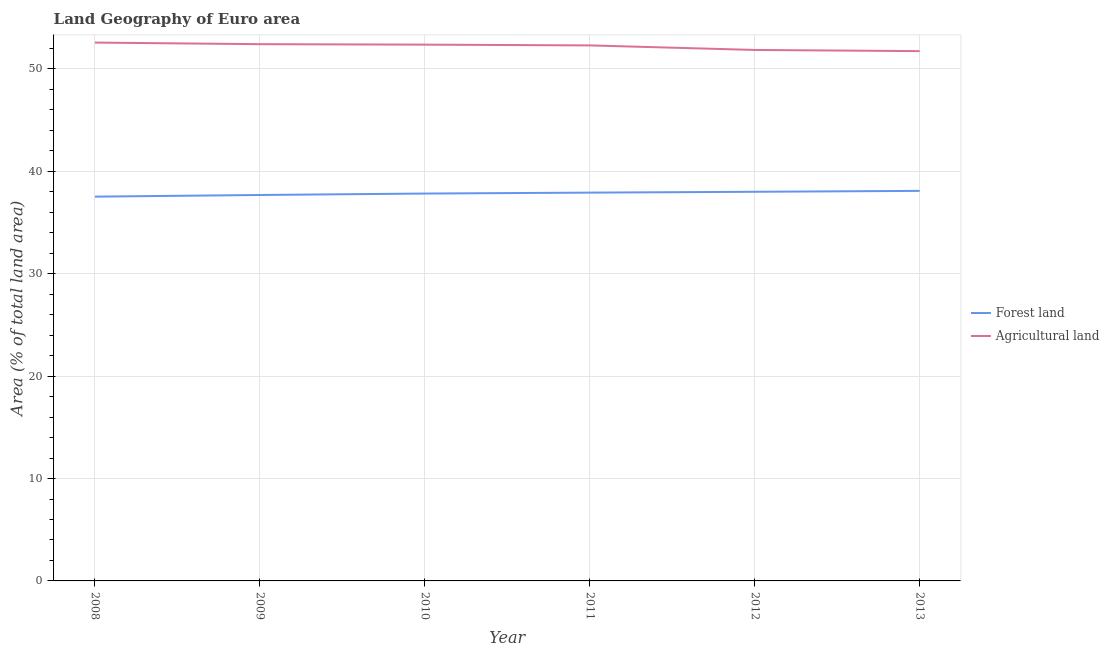Does the line corresponding to percentage of land area under agriculture intersect with the line corresponding to percentage of land area under forests?
Your answer should be very brief. No. Is the number of lines equal to the number of legend labels?
Make the answer very short. Yes. What is the percentage of land area under forests in 2012?
Provide a short and direct response. 38.01. Across all years, what is the maximum percentage of land area under forests?
Provide a short and direct response. 38.09. Across all years, what is the minimum percentage of land area under agriculture?
Provide a short and direct response. 51.74. What is the total percentage of land area under forests in the graph?
Give a very brief answer. 227.08. What is the difference between the percentage of land area under agriculture in 2010 and that in 2013?
Provide a succinct answer. 0.63. What is the difference between the percentage of land area under forests in 2011 and the percentage of land area under agriculture in 2012?
Provide a succinct answer. -13.93. What is the average percentage of land area under forests per year?
Your answer should be very brief. 37.85. In the year 2009, what is the difference between the percentage of land area under forests and percentage of land area under agriculture?
Provide a short and direct response. -14.73. In how many years, is the percentage of land area under forests greater than 22 %?
Provide a short and direct response. 6. What is the ratio of the percentage of land area under agriculture in 2008 to that in 2013?
Ensure brevity in your answer.  1.02. Is the percentage of land area under forests in 2011 less than that in 2013?
Offer a very short reply. Yes. What is the difference between the highest and the second highest percentage of land area under agriculture?
Provide a short and direct response. 0.16. What is the difference between the highest and the lowest percentage of land area under agriculture?
Provide a short and direct response. 0.83. Is the sum of the percentage of land area under agriculture in 2011 and 2013 greater than the maximum percentage of land area under forests across all years?
Make the answer very short. Yes. Is the percentage of land area under forests strictly less than the percentage of land area under agriculture over the years?
Offer a very short reply. Yes. How many years are there in the graph?
Keep it short and to the point. 6. What is the difference between two consecutive major ticks on the Y-axis?
Your response must be concise. 10. Does the graph contain any zero values?
Keep it short and to the point. No. Does the graph contain grids?
Provide a succinct answer. Yes. Where does the legend appear in the graph?
Your response must be concise. Center right. How are the legend labels stacked?
Offer a very short reply. Vertical. What is the title of the graph?
Offer a very short reply. Land Geography of Euro area. Does "Time to import" appear as one of the legend labels in the graph?
Give a very brief answer. No. What is the label or title of the Y-axis?
Make the answer very short. Area (% of total land area). What is the Area (% of total land area) of Forest land in 2008?
Provide a short and direct response. 37.53. What is the Area (% of total land area) in Agricultural land in 2008?
Keep it short and to the point. 52.58. What is the Area (% of total land area) in Forest land in 2009?
Give a very brief answer. 37.69. What is the Area (% of total land area) of Agricultural land in 2009?
Make the answer very short. 52.42. What is the Area (% of total land area) of Forest land in 2010?
Your answer should be very brief. 37.83. What is the Area (% of total land area) of Agricultural land in 2010?
Provide a succinct answer. 52.38. What is the Area (% of total land area) in Forest land in 2011?
Provide a short and direct response. 37.92. What is the Area (% of total land area) of Agricultural land in 2011?
Offer a very short reply. 52.3. What is the Area (% of total land area) in Forest land in 2012?
Ensure brevity in your answer.  38.01. What is the Area (% of total land area) in Agricultural land in 2012?
Provide a short and direct response. 51.86. What is the Area (% of total land area) in Forest land in 2013?
Offer a terse response. 38.09. What is the Area (% of total land area) of Agricultural land in 2013?
Ensure brevity in your answer.  51.74. Across all years, what is the maximum Area (% of total land area) of Forest land?
Give a very brief answer. 38.09. Across all years, what is the maximum Area (% of total land area) of Agricultural land?
Keep it short and to the point. 52.58. Across all years, what is the minimum Area (% of total land area) in Forest land?
Keep it short and to the point. 37.53. Across all years, what is the minimum Area (% of total land area) in Agricultural land?
Your answer should be very brief. 51.74. What is the total Area (% of total land area) of Forest land in the graph?
Give a very brief answer. 227.08. What is the total Area (% of total land area) of Agricultural land in the graph?
Make the answer very short. 313.28. What is the difference between the Area (% of total land area) in Forest land in 2008 and that in 2009?
Provide a succinct answer. -0.16. What is the difference between the Area (% of total land area) in Agricultural land in 2008 and that in 2009?
Provide a short and direct response. 0.16. What is the difference between the Area (% of total land area) of Forest land in 2008 and that in 2010?
Your answer should be compact. -0.3. What is the difference between the Area (% of total land area) in Agricultural land in 2008 and that in 2010?
Give a very brief answer. 0.2. What is the difference between the Area (% of total land area) of Forest land in 2008 and that in 2011?
Provide a short and direct response. -0.39. What is the difference between the Area (% of total land area) of Agricultural land in 2008 and that in 2011?
Make the answer very short. 0.28. What is the difference between the Area (% of total land area) in Forest land in 2008 and that in 2012?
Your answer should be compact. -0.48. What is the difference between the Area (% of total land area) of Agricultural land in 2008 and that in 2012?
Keep it short and to the point. 0.72. What is the difference between the Area (% of total land area) in Forest land in 2008 and that in 2013?
Your answer should be very brief. -0.56. What is the difference between the Area (% of total land area) in Agricultural land in 2008 and that in 2013?
Your answer should be compact. 0.83. What is the difference between the Area (% of total land area) of Forest land in 2009 and that in 2010?
Offer a very short reply. -0.14. What is the difference between the Area (% of total land area) in Agricultural land in 2009 and that in 2010?
Offer a very short reply. 0.05. What is the difference between the Area (% of total land area) of Forest land in 2009 and that in 2011?
Your response must be concise. -0.23. What is the difference between the Area (% of total land area) of Agricultural land in 2009 and that in 2011?
Keep it short and to the point. 0.12. What is the difference between the Area (% of total land area) in Forest land in 2009 and that in 2012?
Your response must be concise. -0.31. What is the difference between the Area (% of total land area) in Agricultural land in 2009 and that in 2012?
Your response must be concise. 0.57. What is the difference between the Area (% of total land area) in Forest land in 2009 and that in 2013?
Provide a succinct answer. -0.4. What is the difference between the Area (% of total land area) of Agricultural land in 2009 and that in 2013?
Provide a succinct answer. 0.68. What is the difference between the Area (% of total land area) of Forest land in 2010 and that in 2011?
Provide a short and direct response. -0.09. What is the difference between the Area (% of total land area) in Agricultural land in 2010 and that in 2011?
Ensure brevity in your answer.  0.08. What is the difference between the Area (% of total land area) in Forest land in 2010 and that in 2012?
Ensure brevity in your answer.  -0.17. What is the difference between the Area (% of total land area) in Agricultural land in 2010 and that in 2012?
Give a very brief answer. 0.52. What is the difference between the Area (% of total land area) of Forest land in 2010 and that in 2013?
Ensure brevity in your answer.  -0.26. What is the difference between the Area (% of total land area) in Agricultural land in 2010 and that in 2013?
Give a very brief answer. 0.63. What is the difference between the Area (% of total land area) of Forest land in 2011 and that in 2012?
Provide a short and direct response. -0.08. What is the difference between the Area (% of total land area) of Agricultural land in 2011 and that in 2012?
Your answer should be compact. 0.44. What is the difference between the Area (% of total land area) of Forest land in 2011 and that in 2013?
Your response must be concise. -0.17. What is the difference between the Area (% of total land area) in Agricultural land in 2011 and that in 2013?
Keep it short and to the point. 0.56. What is the difference between the Area (% of total land area) in Forest land in 2012 and that in 2013?
Make the answer very short. -0.09. What is the difference between the Area (% of total land area) of Agricultural land in 2012 and that in 2013?
Offer a very short reply. 0.11. What is the difference between the Area (% of total land area) of Forest land in 2008 and the Area (% of total land area) of Agricultural land in 2009?
Ensure brevity in your answer.  -14.89. What is the difference between the Area (% of total land area) of Forest land in 2008 and the Area (% of total land area) of Agricultural land in 2010?
Your response must be concise. -14.85. What is the difference between the Area (% of total land area) of Forest land in 2008 and the Area (% of total land area) of Agricultural land in 2011?
Ensure brevity in your answer.  -14.77. What is the difference between the Area (% of total land area) in Forest land in 2008 and the Area (% of total land area) in Agricultural land in 2012?
Your answer should be compact. -14.33. What is the difference between the Area (% of total land area) of Forest land in 2008 and the Area (% of total land area) of Agricultural land in 2013?
Make the answer very short. -14.21. What is the difference between the Area (% of total land area) of Forest land in 2009 and the Area (% of total land area) of Agricultural land in 2010?
Give a very brief answer. -14.68. What is the difference between the Area (% of total land area) in Forest land in 2009 and the Area (% of total land area) in Agricultural land in 2011?
Your response must be concise. -14.61. What is the difference between the Area (% of total land area) of Forest land in 2009 and the Area (% of total land area) of Agricultural land in 2012?
Offer a terse response. -14.16. What is the difference between the Area (% of total land area) of Forest land in 2009 and the Area (% of total land area) of Agricultural land in 2013?
Provide a succinct answer. -14.05. What is the difference between the Area (% of total land area) of Forest land in 2010 and the Area (% of total land area) of Agricultural land in 2011?
Your answer should be compact. -14.47. What is the difference between the Area (% of total land area) of Forest land in 2010 and the Area (% of total land area) of Agricultural land in 2012?
Your answer should be very brief. -14.02. What is the difference between the Area (% of total land area) of Forest land in 2010 and the Area (% of total land area) of Agricultural land in 2013?
Your answer should be very brief. -13.91. What is the difference between the Area (% of total land area) in Forest land in 2011 and the Area (% of total land area) in Agricultural land in 2012?
Keep it short and to the point. -13.93. What is the difference between the Area (% of total land area) of Forest land in 2011 and the Area (% of total land area) of Agricultural land in 2013?
Ensure brevity in your answer.  -13.82. What is the difference between the Area (% of total land area) in Forest land in 2012 and the Area (% of total land area) in Agricultural land in 2013?
Your response must be concise. -13.74. What is the average Area (% of total land area) in Forest land per year?
Give a very brief answer. 37.85. What is the average Area (% of total land area) in Agricultural land per year?
Give a very brief answer. 52.21. In the year 2008, what is the difference between the Area (% of total land area) of Forest land and Area (% of total land area) of Agricultural land?
Your answer should be very brief. -15.05. In the year 2009, what is the difference between the Area (% of total land area) of Forest land and Area (% of total land area) of Agricultural land?
Offer a terse response. -14.73. In the year 2010, what is the difference between the Area (% of total land area) of Forest land and Area (% of total land area) of Agricultural land?
Your response must be concise. -14.54. In the year 2011, what is the difference between the Area (% of total land area) of Forest land and Area (% of total land area) of Agricultural land?
Offer a terse response. -14.38. In the year 2012, what is the difference between the Area (% of total land area) of Forest land and Area (% of total land area) of Agricultural land?
Give a very brief answer. -13.85. In the year 2013, what is the difference between the Area (% of total land area) of Forest land and Area (% of total land area) of Agricultural land?
Your answer should be compact. -13.65. What is the ratio of the Area (% of total land area) in Agricultural land in 2008 to that in 2009?
Ensure brevity in your answer.  1. What is the ratio of the Area (% of total land area) of Forest land in 2008 to that in 2010?
Your response must be concise. 0.99. What is the ratio of the Area (% of total land area) of Agricultural land in 2008 to that in 2010?
Provide a succinct answer. 1. What is the ratio of the Area (% of total land area) in Forest land in 2008 to that in 2011?
Offer a terse response. 0.99. What is the ratio of the Area (% of total land area) in Forest land in 2008 to that in 2012?
Provide a succinct answer. 0.99. What is the ratio of the Area (% of total land area) of Agricultural land in 2008 to that in 2012?
Provide a short and direct response. 1.01. What is the ratio of the Area (% of total land area) in Forest land in 2008 to that in 2013?
Ensure brevity in your answer.  0.99. What is the ratio of the Area (% of total land area) in Agricultural land in 2008 to that in 2013?
Offer a very short reply. 1.02. What is the ratio of the Area (% of total land area) of Forest land in 2009 to that in 2010?
Offer a terse response. 1. What is the ratio of the Area (% of total land area) in Agricultural land in 2009 to that in 2010?
Your answer should be compact. 1. What is the ratio of the Area (% of total land area) in Agricultural land in 2009 to that in 2011?
Your response must be concise. 1. What is the ratio of the Area (% of total land area) of Forest land in 2009 to that in 2012?
Your answer should be compact. 0.99. What is the ratio of the Area (% of total land area) of Agricultural land in 2009 to that in 2012?
Keep it short and to the point. 1.01. What is the ratio of the Area (% of total land area) in Forest land in 2009 to that in 2013?
Offer a very short reply. 0.99. What is the ratio of the Area (% of total land area) in Agricultural land in 2009 to that in 2013?
Your answer should be very brief. 1.01. What is the ratio of the Area (% of total land area) in Forest land in 2010 to that in 2011?
Your answer should be compact. 1. What is the ratio of the Area (% of total land area) of Agricultural land in 2010 to that in 2011?
Your answer should be compact. 1. What is the ratio of the Area (% of total land area) of Forest land in 2010 to that in 2013?
Your response must be concise. 0.99. What is the ratio of the Area (% of total land area) of Agricultural land in 2010 to that in 2013?
Provide a short and direct response. 1.01. What is the ratio of the Area (% of total land area) of Forest land in 2011 to that in 2012?
Ensure brevity in your answer.  1. What is the ratio of the Area (% of total land area) in Agricultural land in 2011 to that in 2012?
Ensure brevity in your answer.  1.01. What is the ratio of the Area (% of total land area) of Agricultural land in 2011 to that in 2013?
Your response must be concise. 1.01. What is the ratio of the Area (% of total land area) in Forest land in 2012 to that in 2013?
Make the answer very short. 1. What is the difference between the highest and the second highest Area (% of total land area) in Forest land?
Your response must be concise. 0.09. What is the difference between the highest and the second highest Area (% of total land area) of Agricultural land?
Provide a succinct answer. 0.16. What is the difference between the highest and the lowest Area (% of total land area) of Forest land?
Offer a very short reply. 0.56. What is the difference between the highest and the lowest Area (% of total land area) in Agricultural land?
Ensure brevity in your answer.  0.83. 